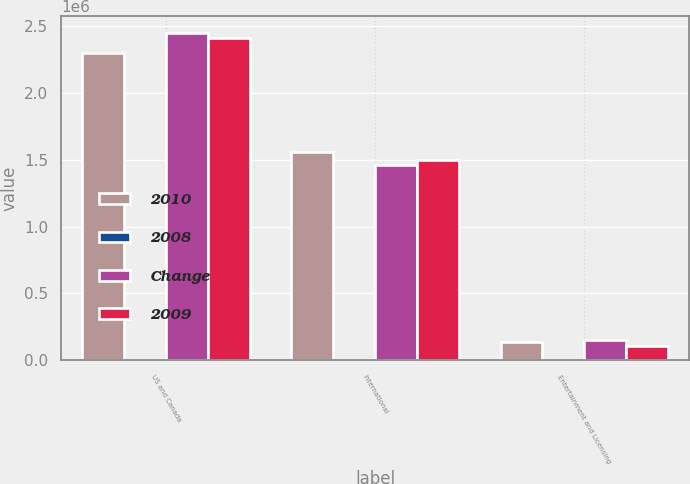Convert chart. <chart><loc_0><loc_0><loc_500><loc_500><stacked_bar_chart><ecel><fcel>US and Canada<fcel>International<fcel>Entertainment and Licensing<nl><fcel>2010<fcel>2.29955e+06<fcel>1.55993e+06<fcel>136488<nl><fcel>2008<fcel>6<fcel>7<fcel>12<nl><fcel>Change<fcel>2.44794e+06<fcel>1.45948e+06<fcel>155013<nl><fcel>2009<fcel>2.40674e+06<fcel>1.49933e+06<fcel>107929<nl></chart> 